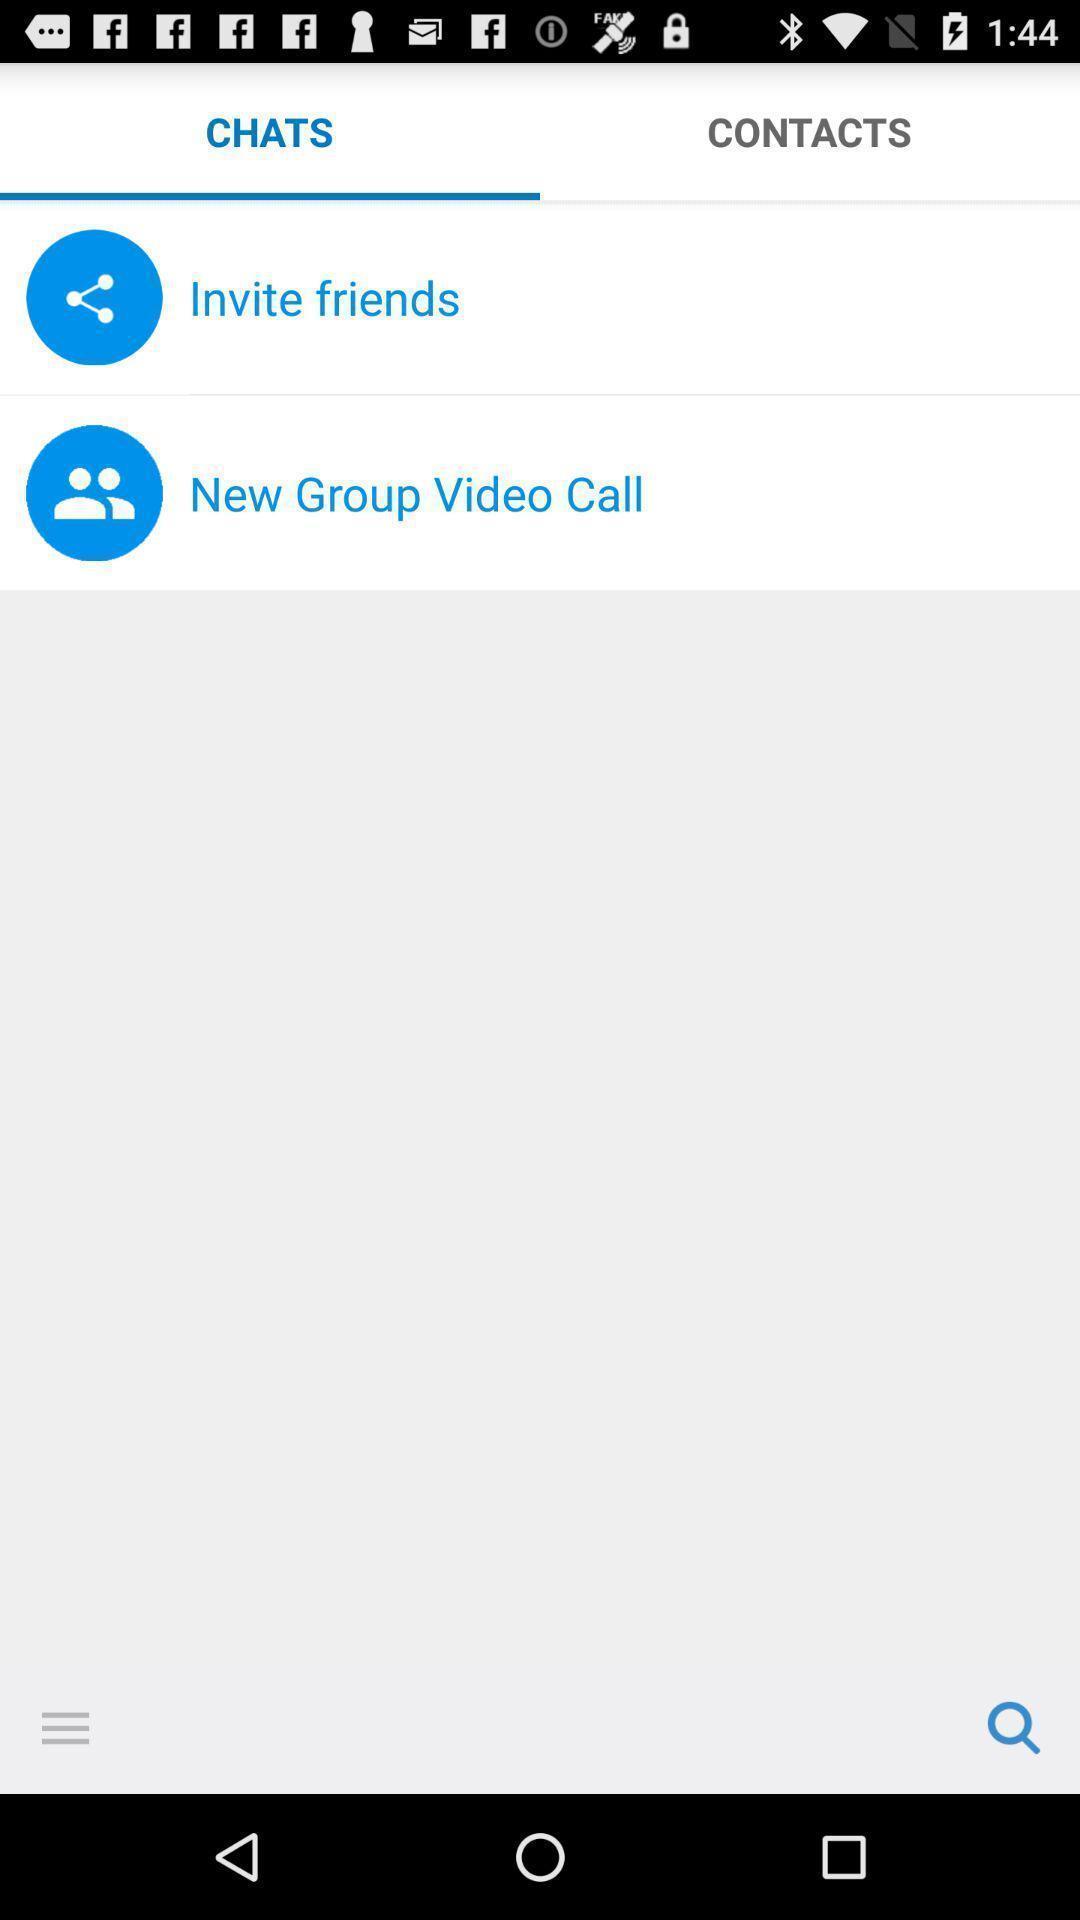Provide a textual representation of this image. Page displaying two options in the app. 